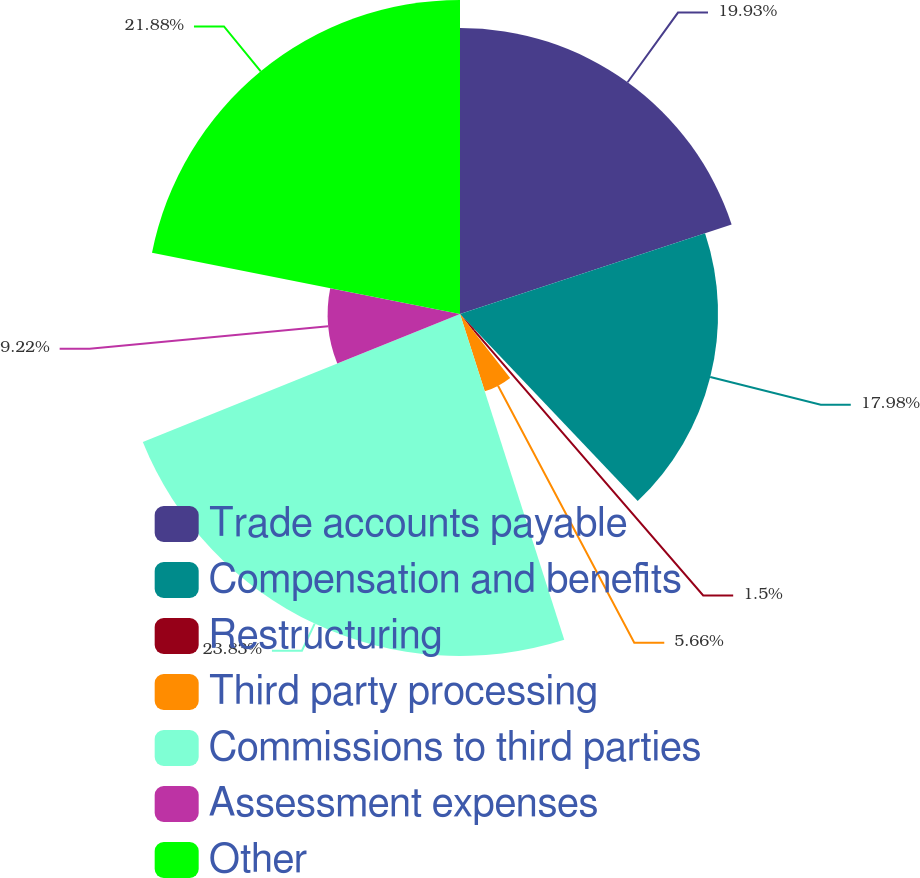<chart> <loc_0><loc_0><loc_500><loc_500><pie_chart><fcel>Trade accounts payable<fcel>Compensation and benefits<fcel>Restructuring<fcel>Third party processing<fcel>Commissions to third parties<fcel>Assessment expenses<fcel>Other<nl><fcel>19.93%<fcel>17.98%<fcel>1.5%<fcel>5.66%<fcel>23.83%<fcel>9.22%<fcel>21.88%<nl></chart> 